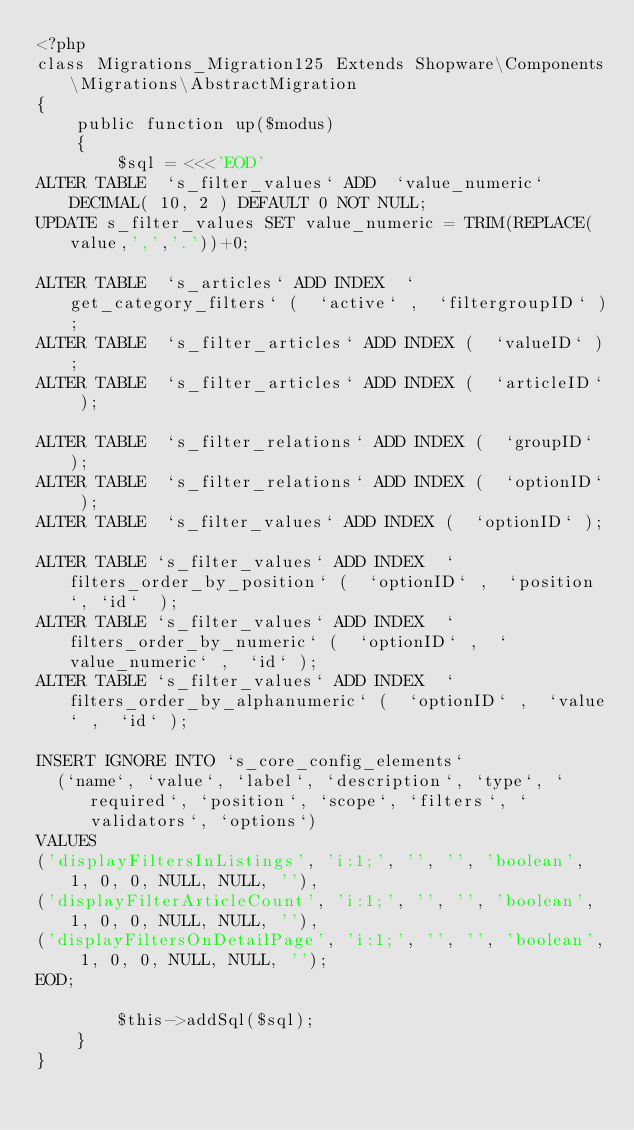<code> <loc_0><loc_0><loc_500><loc_500><_PHP_><?php
class Migrations_Migration125 Extends Shopware\Components\Migrations\AbstractMigration
{
    public function up($modus)
    {
        $sql = <<<'EOD'
ALTER TABLE  `s_filter_values` ADD  `value_numeric`  DECIMAL( 10, 2 ) DEFAULT 0 NOT NULL;
UPDATE s_filter_values SET value_numeric = TRIM(REPLACE(value,',','.'))+0;

ALTER TABLE  `s_articles` ADD INDEX  `get_category_filters` (  `active` ,  `filtergroupID` );
ALTER TABLE  `s_filter_articles` ADD INDEX (  `valueID` );
ALTER TABLE  `s_filter_articles` ADD INDEX (  `articleID` );

ALTER TABLE  `s_filter_relations` ADD INDEX (  `groupID` );
ALTER TABLE  `s_filter_relations` ADD INDEX (  `optionID` );
ALTER TABLE  `s_filter_values` ADD INDEX (  `optionID` );

ALTER TABLE `s_filter_values` ADD INDEX  `filters_order_by_position` (  `optionID` ,  `position`, `id`  );
ALTER TABLE `s_filter_values` ADD INDEX  `filters_order_by_numeric` (  `optionID` ,  `value_numeric` ,  `id` );
ALTER TABLE `s_filter_values` ADD INDEX  `filters_order_by_alphanumeric` (  `optionID` ,  `value` ,  `id` );

INSERT IGNORE INTO `s_core_config_elements`
  (`name`, `value`, `label`, `description`, `type`, `required`, `position`, `scope`, `filters`, `validators`, `options`)
VALUES
('displayFiltersInListings', 'i:1;', '', '', 'boolean', 1, 0, 0, NULL, NULL, ''),
('displayFilterArticleCount', 'i:1;', '', '', 'boolean', 1, 0, 0, NULL, NULL, ''),
('displayFiltersOnDetailPage', 'i:1;', '', '', 'boolean', 1, 0, 0, NULL, NULL, '');
EOD;

        $this->addSql($sql);
    }
}
</code> 